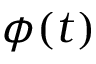<formula> <loc_0><loc_0><loc_500><loc_500>\phi ( t )</formula> 